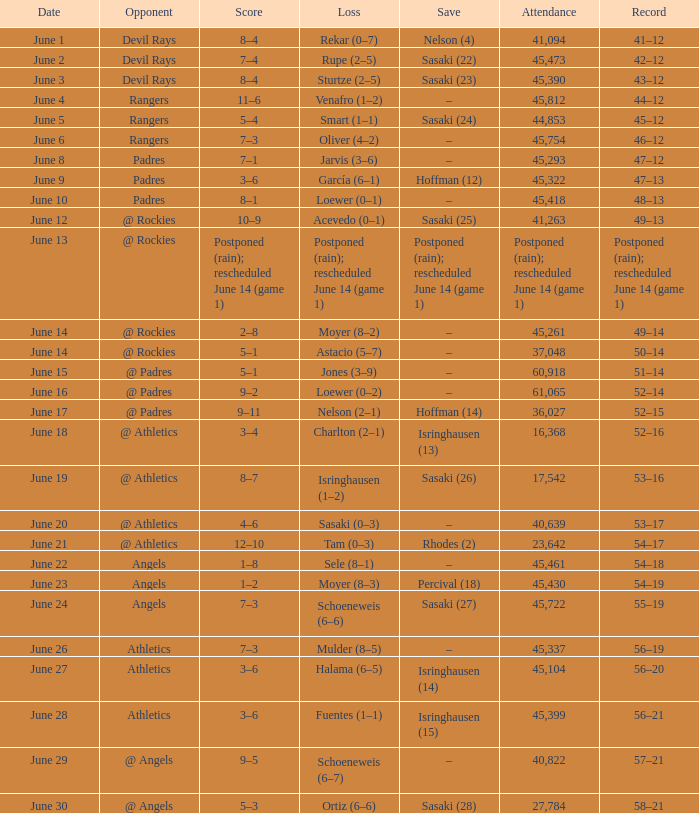When the mariners had a 56-21 record, what was the score of that specific game? 3–6. 